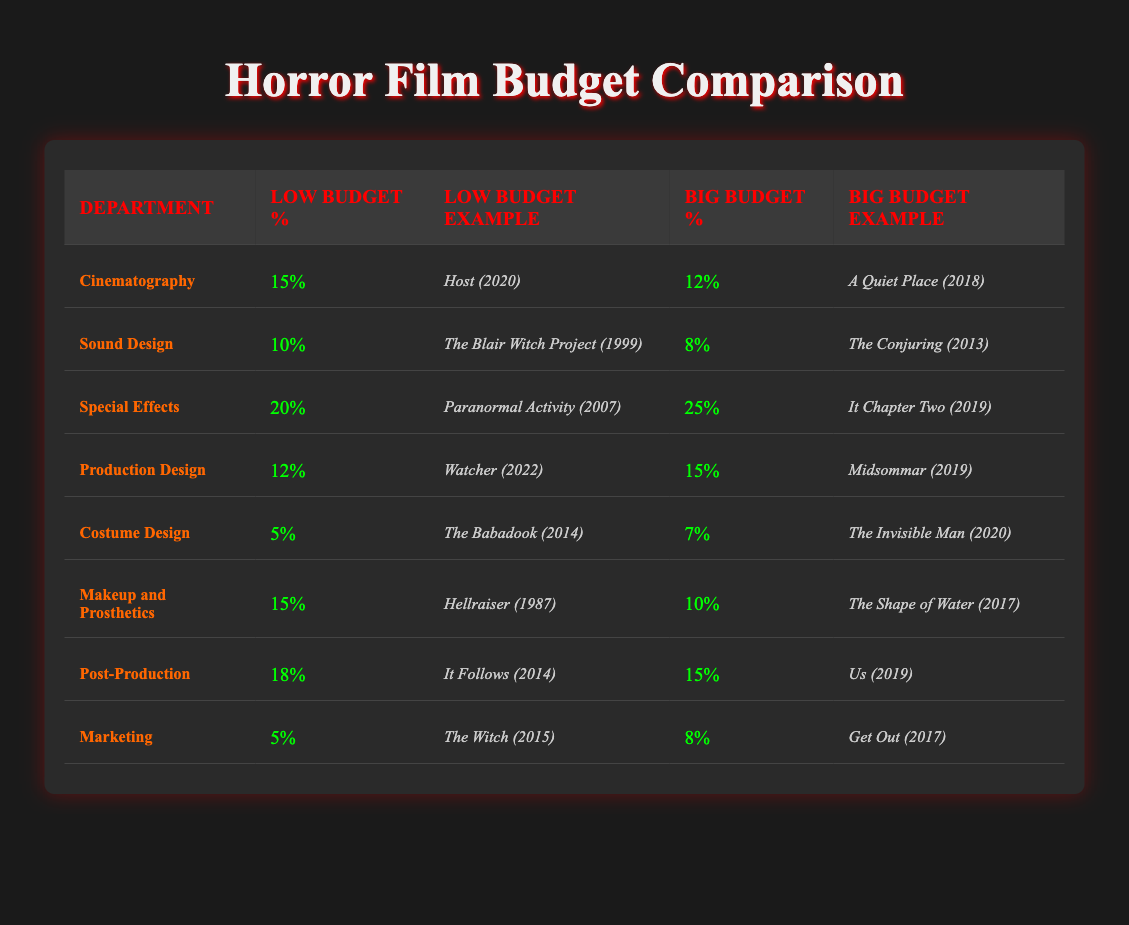What is the department that receives the highest percentage of the budget in low-budget horror films? In the low-budget category, Special Effects receive the highest percentage at 20%. This is directly noted in the table under the "Low Budget %" column for Special Effects.
Answer: Special Effects Which department has a larger budget percentage in big-budget horror films, Production Design or Makeup and Prosthetics? In the big-budget category, Production Design receives 15% while Makeup and Prosthetics receive 10%. Therefore, Production Design has a larger budget percentage.
Answer: Production Design What is the total percentage allocated to Sound Design in both low-budget and big-budget horror films? From the table, Sound Design receives 10% in low-budget and 8% in big-budget films. Adding these together gives 10 + 8 = 18%.
Answer: 18% Is the allocation for Cinematography higher in low-budget or big-budget horror films? In low-budget horror films, Cinematography is allocated 15%, while in big-budget films it is 12%. Hence, the allocation is higher in low-budget horror films.
Answer: Low-budget horror films How much more percentage is allocated to Special Effects in big-budget films compared to low-budget films? Special Effects receive 25% in big-budget horror films and 20% in low-budget films. The difference is 25 - 20 = 5%, meaning big-budget films allocate 5% more to Special Effects.
Answer: 5% more What was the lowest budget allocation percentage for both categories? In the low-budget category, the lowest allocation is 5% for both Costume Design and Marketing. In big-budget horror films, the lowest is 7% for Costume Design. Therefore, the overall lowest is 5%.
Answer: 5% Which low-budget horror film example is connected to the highest budget percentage? The highest budget percentage in low-budget horror is for Special Effects at 20%, and the corresponding example given is "Paranormal Activity (2007)."
Answer: Paranormal Activity (2007) Does Costume Design receive more budget allocation in low-budget or big-budget films? In low-budget horror films, Costume Design has 5% while in big-budget films it receives 7%. Thus, it receives more in big-budget films.
Answer: Big-budget films 